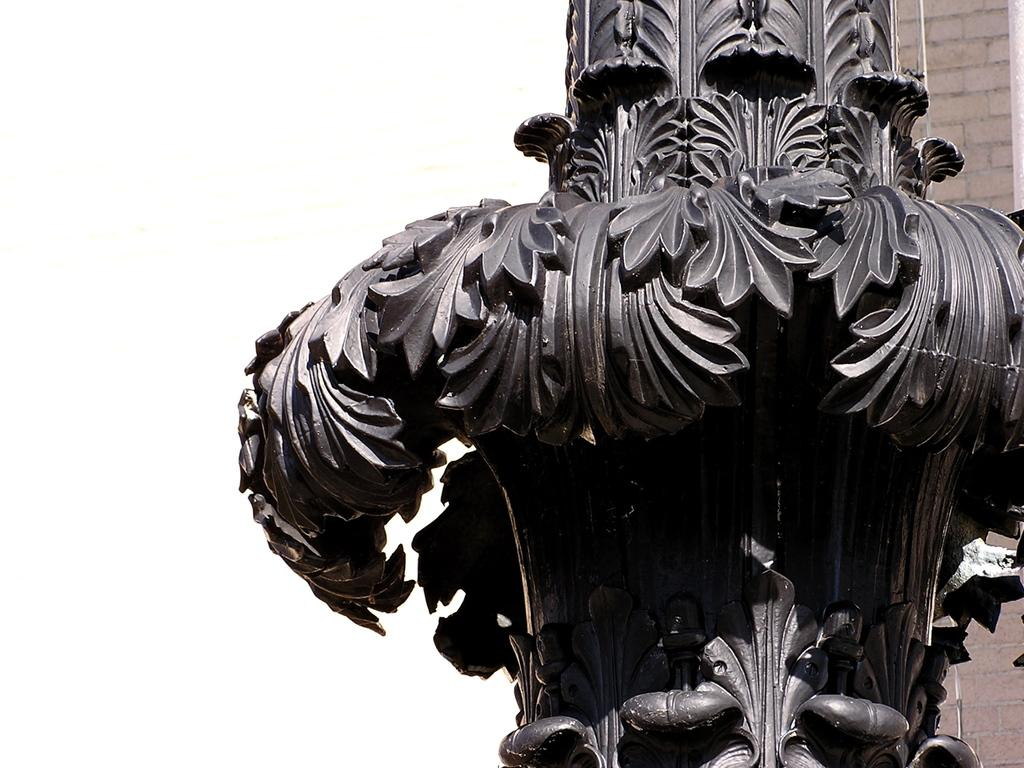What is the main subject in the image? There is a pillar in the image. What makes the pillar stand out? The pillar has beautiful carvings. What type of bone can be seen in the image? There is no bone present in the image; it features a pillar with beautiful carvings. 